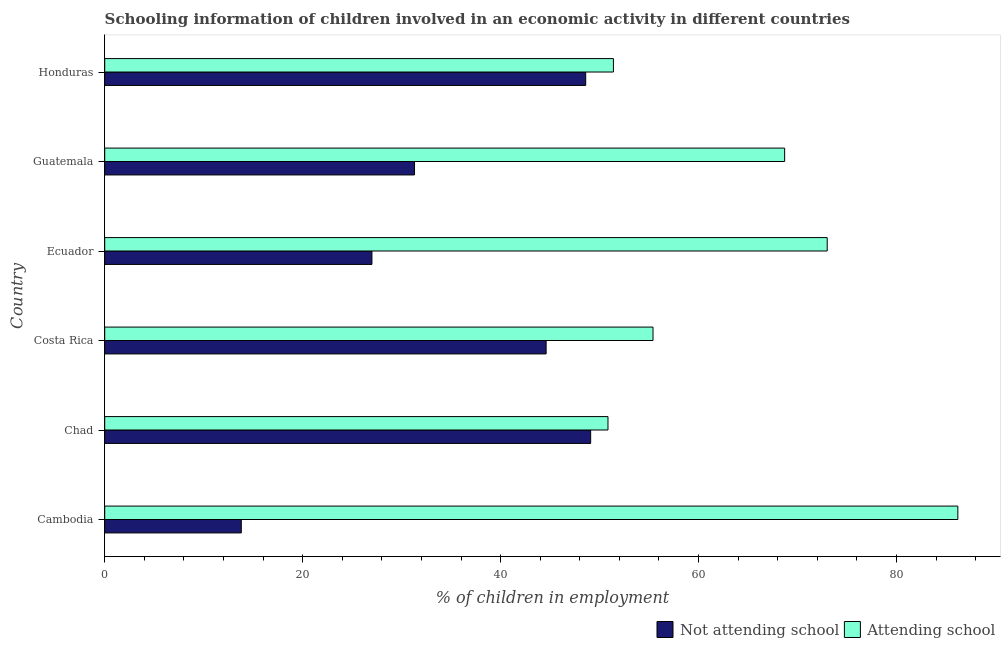Are the number of bars on each tick of the Y-axis equal?
Make the answer very short. Yes. How many bars are there on the 5th tick from the top?
Offer a terse response. 2. How many bars are there on the 3rd tick from the bottom?
Make the answer very short. 2. What is the label of the 2nd group of bars from the top?
Offer a very short reply. Guatemala. What is the percentage of employed children who are attending school in Guatemala?
Your answer should be very brief. 68.7. Across all countries, what is the maximum percentage of employed children who are attending school?
Ensure brevity in your answer.  86.2. In which country was the percentage of employed children who are not attending school maximum?
Make the answer very short. Chad. In which country was the percentage of employed children who are attending school minimum?
Your answer should be compact. Chad. What is the total percentage of employed children who are attending school in the graph?
Offer a terse response. 385.55. What is the difference between the percentage of employed children who are not attending school in Ecuador and the percentage of employed children who are attending school in Guatemala?
Make the answer very short. -41.7. What is the average percentage of employed children who are not attending school per country?
Your response must be concise. 35.73. What is the difference between the percentage of employed children who are attending school and percentage of employed children who are not attending school in Ecuador?
Offer a terse response. 46. In how many countries, is the percentage of employed children who are attending school greater than 48 %?
Your answer should be very brief. 6. What is the ratio of the percentage of employed children who are not attending school in Cambodia to that in Honduras?
Provide a short and direct response. 0.28. Is the percentage of employed children who are attending school in Cambodia less than that in Guatemala?
Offer a very short reply. No. Is the difference between the percentage of employed children who are not attending school in Ecuador and Honduras greater than the difference between the percentage of employed children who are attending school in Ecuador and Honduras?
Give a very brief answer. No. What is the difference between the highest and the lowest percentage of employed children who are not attending school?
Your answer should be compact. 35.3. In how many countries, is the percentage of employed children who are not attending school greater than the average percentage of employed children who are not attending school taken over all countries?
Your answer should be very brief. 3. Is the sum of the percentage of employed children who are attending school in Cambodia and Costa Rica greater than the maximum percentage of employed children who are not attending school across all countries?
Your answer should be very brief. Yes. What does the 2nd bar from the top in Chad represents?
Provide a succinct answer. Not attending school. What does the 2nd bar from the bottom in Cambodia represents?
Your answer should be very brief. Attending school. Are all the bars in the graph horizontal?
Offer a terse response. Yes. What is the difference between two consecutive major ticks on the X-axis?
Keep it short and to the point. 20. Are the values on the major ticks of X-axis written in scientific E-notation?
Your answer should be very brief. No. Does the graph contain any zero values?
Offer a terse response. No. How are the legend labels stacked?
Your answer should be very brief. Horizontal. What is the title of the graph?
Provide a succinct answer. Schooling information of children involved in an economic activity in different countries. Does "Exports of goods" appear as one of the legend labels in the graph?
Offer a terse response. No. What is the label or title of the X-axis?
Provide a short and direct response. % of children in employment. What is the % of children in employment in Not attending school in Cambodia?
Your response must be concise. 13.8. What is the % of children in employment in Attending school in Cambodia?
Keep it short and to the point. 86.2. What is the % of children in employment of Not attending school in Chad?
Offer a terse response. 49.1. What is the % of children in employment in Attending school in Chad?
Make the answer very short. 50.85. What is the % of children in employment in Not attending school in Costa Rica?
Provide a succinct answer. 44.6. What is the % of children in employment in Attending school in Costa Rica?
Your answer should be compact. 55.4. What is the % of children in employment of Not attending school in Ecuador?
Keep it short and to the point. 27. What is the % of children in employment of Attending school in Ecuador?
Your response must be concise. 73. What is the % of children in employment of Not attending school in Guatemala?
Make the answer very short. 31.3. What is the % of children in employment in Attending school in Guatemala?
Ensure brevity in your answer.  68.7. What is the % of children in employment of Not attending school in Honduras?
Offer a terse response. 48.6. What is the % of children in employment in Attending school in Honduras?
Your response must be concise. 51.4. Across all countries, what is the maximum % of children in employment in Not attending school?
Your answer should be very brief. 49.1. Across all countries, what is the maximum % of children in employment in Attending school?
Provide a short and direct response. 86.2. Across all countries, what is the minimum % of children in employment in Attending school?
Ensure brevity in your answer.  50.85. What is the total % of children in employment of Not attending school in the graph?
Your answer should be very brief. 214.4. What is the total % of children in employment in Attending school in the graph?
Give a very brief answer. 385.55. What is the difference between the % of children in employment of Not attending school in Cambodia and that in Chad?
Ensure brevity in your answer.  -35.3. What is the difference between the % of children in employment of Attending school in Cambodia and that in Chad?
Offer a very short reply. 35.35. What is the difference between the % of children in employment of Not attending school in Cambodia and that in Costa Rica?
Your response must be concise. -30.8. What is the difference between the % of children in employment in Attending school in Cambodia and that in Costa Rica?
Your answer should be very brief. 30.8. What is the difference between the % of children in employment in Not attending school in Cambodia and that in Guatemala?
Your answer should be very brief. -17.5. What is the difference between the % of children in employment of Attending school in Cambodia and that in Guatemala?
Your response must be concise. 17.5. What is the difference between the % of children in employment of Not attending school in Cambodia and that in Honduras?
Your answer should be compact. -34.8. What is the difference between the % of children in employment in Attending school in Cambodia and that in Honduras?
Ensure brevity in your answer.  34.8. What is the difference between the % of children in employment in Attending school in Chad and that in Costa Rica?
Keep it short and to the point. -4.55. What is the difference between the % of children in employment of Not attending school in Chad and that in Ecuador?
Provide a succinct answer. 22.1. What is the difference between the % of children in employment of Attending school in Chad and that in Ecuador?
Offer a very short reply. -22.15. What is the difference between the % of children in employment in Not attending school in Chad and that in Guatemala?
Your response must be concise. 17.8. What is the difference between the % of children in employment in Attending school in Chad and that in Guatemala?
Your answer should be compact. -17.85. What is the difference between the % of children in employment of Attending school in Chad and that in Honduras?
Your answer should be compact. -0.55. What is the difference between the % of children in employment in Attending school in Costa Rica and that in Ecuador?
Ensure brevity in your answer.  -17.6. What is the difference between the % of children in employment in Not attending school in Costa Rica and that in Guatemala?
Offer a terse response. 13.3. What is the difference between the % of children in employment of Attending school in Costa Rica and that in Guatemala?
Ensure brevity in your answer.  -13.3. What is the difference between the % of children in employment in Not attending school in Costa Rica and that in Honduras?
Offer a terse response. -4. What is the difference between the % of children in employment of Attending school in Costa Rica and that in Honduras?
Give a very brief answer. 4. What is the difference between the % of children in employment in Attending school in Ecuador and that in Guatemala?
Your answer should be very brief. 4.3. What is the difference between the % of children in employment of Not attending school in Ecuador and that in Honduras?
Your answer should be very brief. -21.6. What is the difference between the % of children in employment of Attending school in Ecuador and that in Honduras?
Give a very brief answer. 21.6. What is the difference between the % of children in employment of Not attending school in Guatemala and that in Honduras?
Make the answer very short. -17.3. What is the difference between the % of children in employment of Not attending school in Cambodia and the % of children in employment of Attending school in Chad?
Your response must be concise. -37.05. What is the difference between the % of children in employment in Not attending school in Cambodia and the % of children in employment in Attending school in Costa Rica?
Offer a very short reply. -41.6. What is the difference between the % of children in employment in Not attending school in Cambodia and the % of children in employment in Attending school in Ecuador?
Your response must be concise. -59.2. What is the difference between the % of children in employment in Not attending school in Cambodia and the % of children in employment in Attending school in Guatemala?
Offer a terse response. -54.9. What is the difference between the % of children in employment in Not attending school in Cambodia and the % of children in employment in Attending school in Honduras?
Provide a short and direct response. -37.6. What is the difference between the % of children in employment of Not attending school in Chad and the % of children in employment of Attending school in Ecuador?
Your response must be concise. -23.9. What is the difference between the % of children in employment of Not attending school in Chad and the % of children in employment of Attending school in Guatemala?
Ensure brevity in your answer.  -19.6. What is the difference between the % of children in employment of Not attending school in Costa Rica and the % of children in employment of Attending school in Ecuador?
Keep it short and to the point. -28.4. What is the difference between the % of children in employment in Not attending school in Costa Rica and the % of children in employment in Attending school in Guatemala?
Offer a terse response. -24.1. What is the difference between the % of children in employment of Not attending school in Ecuador and the % of children in employment of Attending school in Guatemala?
Provide a short and direct response. -41.7. What is the difference between the % of children in employment of Not attending school in Ecuador and the % of children in employment of Attending school in Honduras?
Provide a succinct answer. -24.4. What is the difference between the % of children in employment in Not attending school in Guatemala and the % of children in employment in Attending school in Honduras?
Your response must be concise. -20.1. What is the average % of children in employment in Not attending school per country?
Provide a short and direct response. 35.73. What is the average % of children in employment of Attending school per country?
Provide a succinct answer. 64.26. What is the difference between the % of children in employment in Not attending school and % of children in employment in Attending school in Cambodia?
Your answer should be compact. -72.4. What is the difference between the % of children in employment of Not attending school and % of children in employment of Attending school in Chad?
Keep it short and to the point. -1.75. What is the difference between the % of children in employment of Not attending school and % of children in employment of Attending school in Ecuador?
Offer a terse response. -46. What is the difference between the % of children in employment of Not attending school and % of children in employment of Attending school in Guatemala?
Ensure brevity in your answer.  -37.4. What is the ratio of the % of children in employment in Not attending school in Cambodia to that in Chad?
Offer a very short reply. 0.28. What is the ratio of the % of children in employment in Attending school in Cambodia to that in Chad?
Give a very brief answer. 1.7. What is the ratio of the % of children in employment in Not attending school in Cambodia to that in Costa Rica?
Keep it short and to the point. 0.31. What is the ratio of the % of children in employment in Attending school in Cambodia to that in Costa Rica?
Keep it short and to the point. 1.56. What is the ratio of the % of children in employment in Not attending school in Cambodia to that in Ecuador?
Offer a very short reply. 0.51. What is the ratio of the % of children in employment in Attending school in Cambodia to that in Ecuador?
Offer a terse response. 1.18. What is the ratio of the % of children in employment of Not attending school in Cambodia to that in Guatemala?
Your response must be concise. 0.44. What is the ratio of the % of children in employment in Attending school in Cambodia to that in Guatemala?
Ensure brevity in your answer.  1.25. What is the ratio of the % of children in employment of Not attending school in Cambodia to that in Honduras?
Make the answer very short. 0.28. What is the ratio of the % of children in employment of Attending school in Cambodia to that in Honduras?
Ensure brevity in your answer.  1.68. What is the ratio of the % of children in employment of Not attending school in Chad to that in Costa Rica?
Make the answer very short. 1.1. What is the ratio of the % of children in employment of Attending school in Chad to that in Costa Rica?
Provide a succinct answer. 0.92. What is the ratio of the % of children in employment of Not attending school in Chad to that in Ecuador?
Provide a short and direct response. 1.82. What is the ratio of the % of children in employment in Attending school in Chad to that in Ecuador?
Your answer should be compact. 0.7. What is the ratio of the % of children in employment of Not attending school in Chad to that in Guatemala?
Give a very brief answer. 1.57. What is the ratio of the % of children in employment of Attending school in Chad to that in Guatemala?
Your answer should be compact. 0.74. What is the ratio of the % of children in employment of Not attending school in Chad to that in Honduras?
Make the answer very short. 1.01. What is the ratio of the % of children in employment of Attending school in Chad to that in Honduras?
Provide a short and direct response. 0.99. What is the ratio of the % of children in employment in Not attending school in Costa Rica to that in Ecuador?
Keep it short and to the point. 1.65. What is the ratio of the % of children in employment of Attending school in Costa Rica to that in Ecuador?
Make the answer very short. 0.76. What is the ratio of the % of children in employment of Not attending school in Costa Rica to that in Guatemala?
Your answer should be compact. 1.42. What is the ratio of the % of children in employment of Attending school in Costa Rica to that in Guatemala?
Offer a terse response. 0.81. What is the ratio of the % of children in employment in Not attending school in Costa Rica to that in Honduras?
Keep it short and to the point. 0.92. What is the ratio of the % of children in employment of Attending school in Costa Rica to that in Honduras?
Provide a succinct answer. 1.08. What is the ratio of the % of children in employment of Not attending school in Ecuador to that in Guatemala?
Offer a very short reply. 0.86. What is the ratio of the % of children in employment in Attending school in Ecuador to that in Guatemala?
Your response must be concise. 1.06. What is the ratio of the % of children in employment in Not attending school in Ecuador to that in Honduras?
Give a very brief answer. 0.56. What is the ratio of the % of children in employment in Attending school in Ecuador to that in Honduras?
Give a very brief answer. 1.42. What is the ratio of the % of children in employment of Not attending school in Guatemala to that in Honduras?
Offer a very short reply. 0.64. What is the ratio of the % of children in employment in Attending school in Guatemala to that in Honduras?
Your response must be concise. 1.34. What is the difference between the highest and the lowest % of children in employment of Not attending school?
Provide a succinct answer. 35.3. What is the difference between the highest and the lowest % of children in employment of Attending school?
Your answer should be very brief. 35.35. 